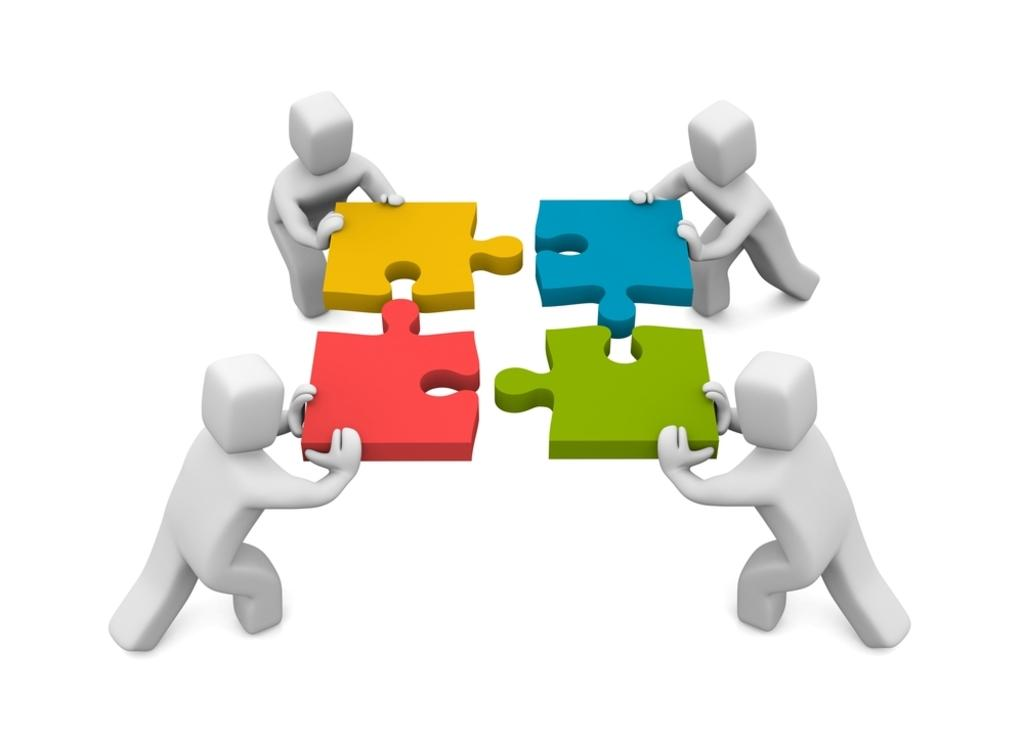What objects are present in the animation? There are blocks in the animation. Are there any living beings in the animation? Yes, there are people in the animation. What type of board can be seen in the animation? There is no board present in the animation; it features blocks and people. How many men are visible in the animation? The provided facts do not mention the gender of the people in the animation, so it cannot be determined from the information given. 